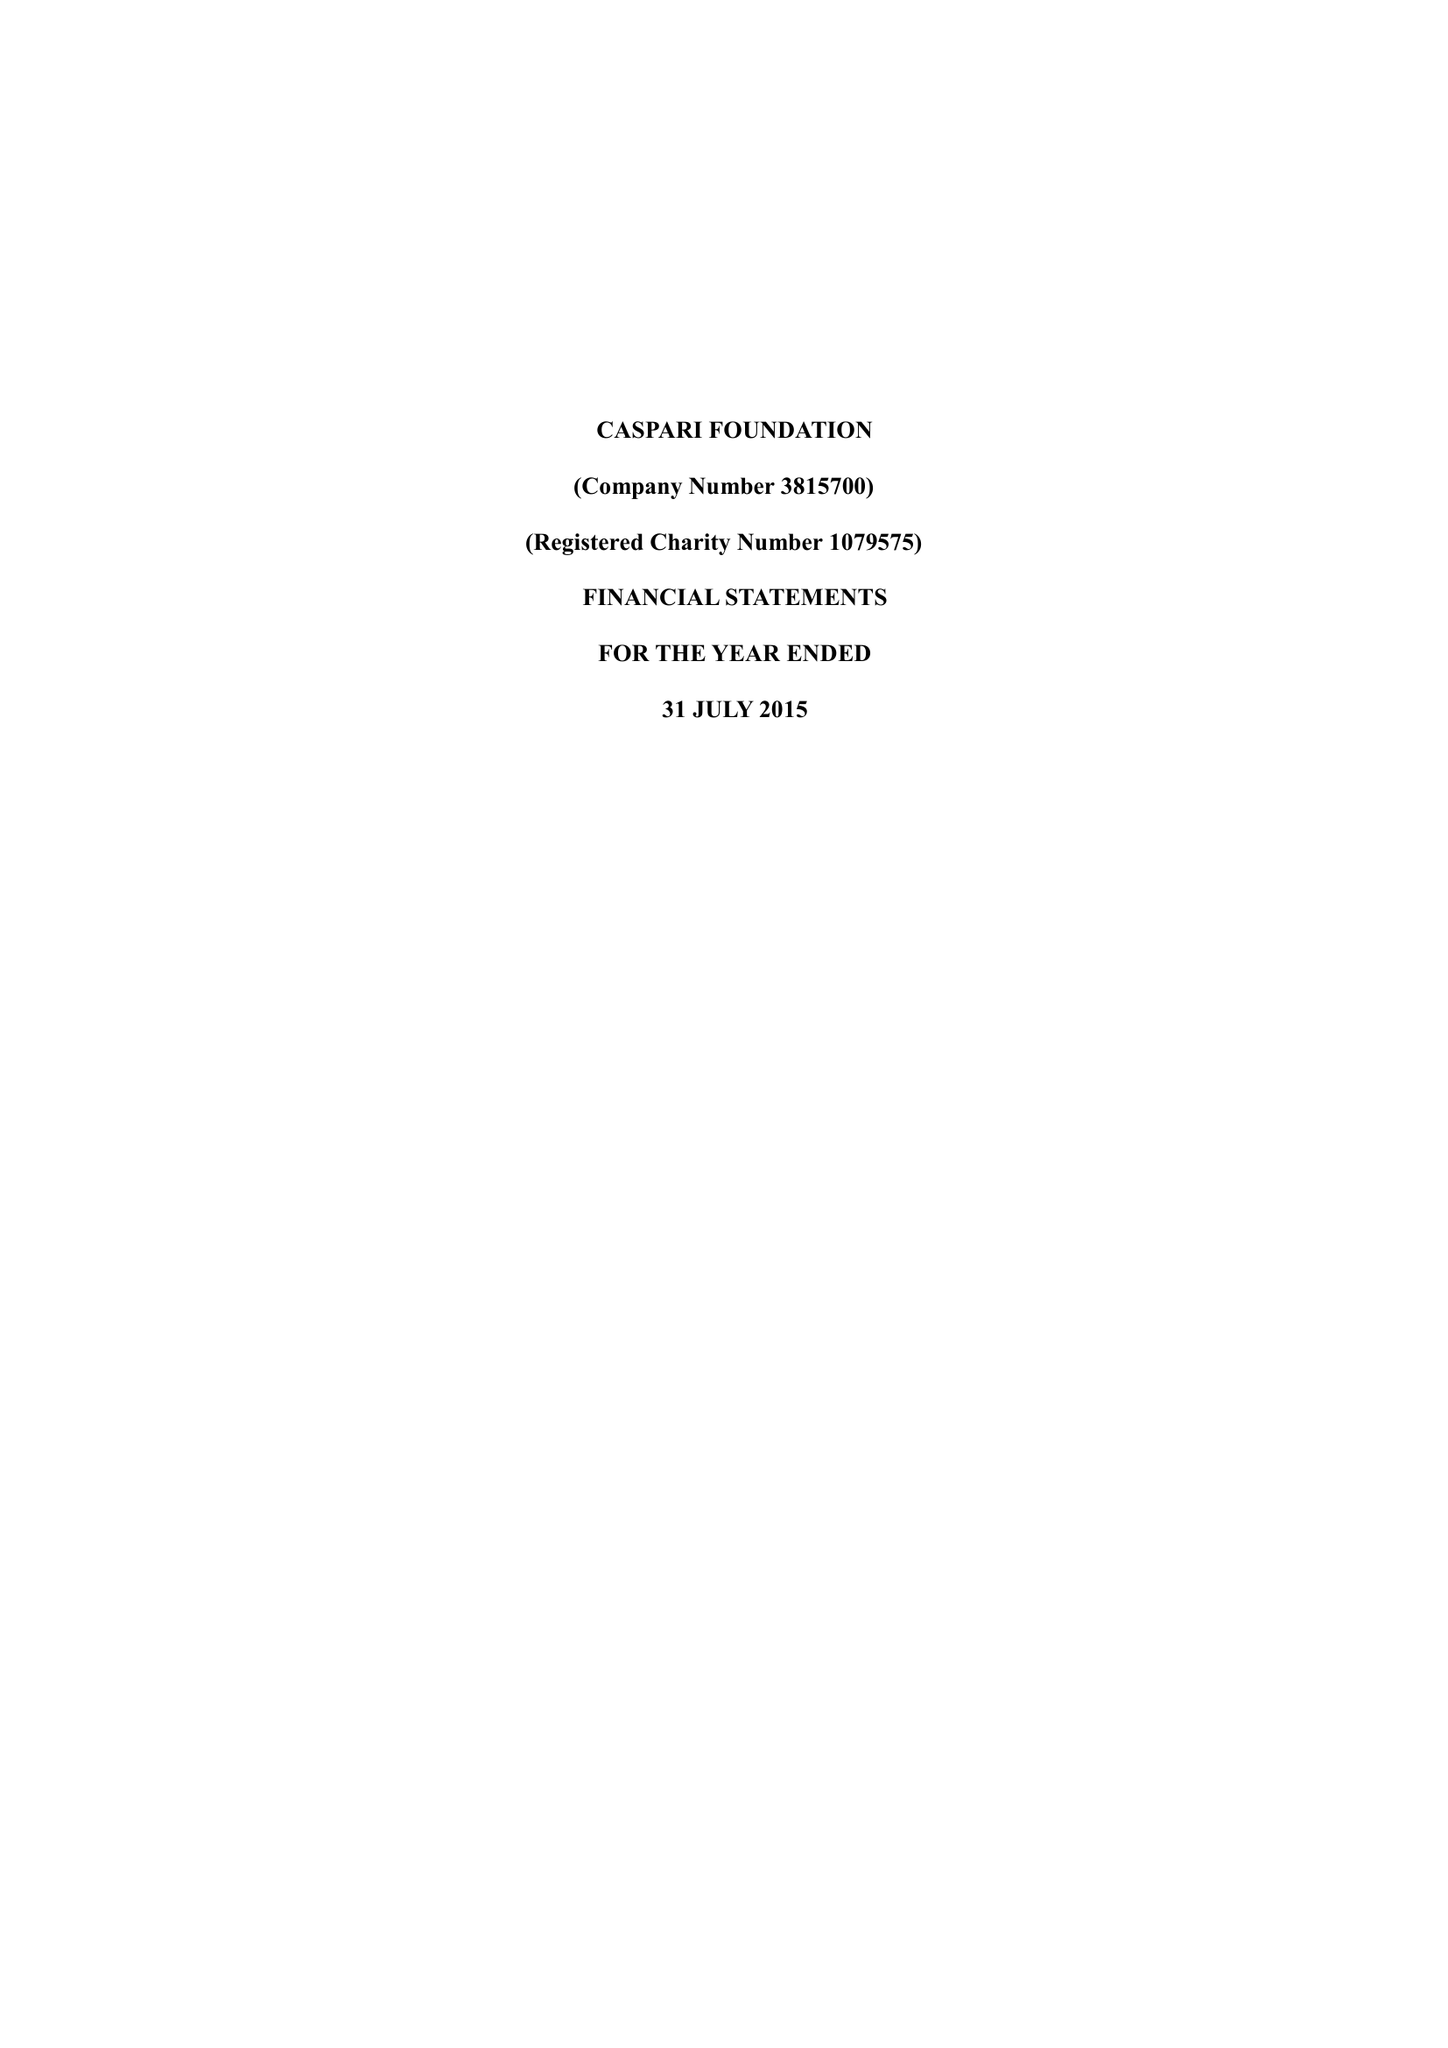What is the value for the address__street_line?
Answer the question using a single word or phrase. 225-229 SEVEN SISTERS ROAD 